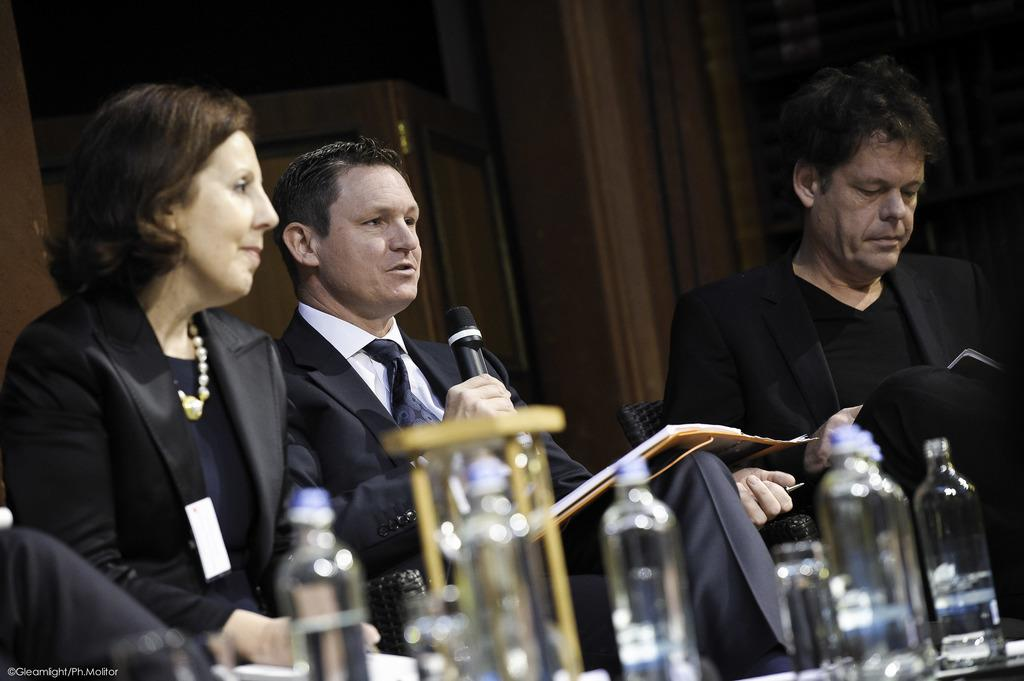How many people are sitting in the image? There are three people sitting in the image. What is the person in the middle doing? The person in the middle is holding a microphone and talking. What can be seen on the table in the image? There are bottles placed on the table. What type of horn is being used by the person in the middle to make a payment in the image? There is no horn or payment being made in the image; the person in the middle is holding a microphone and talking. 